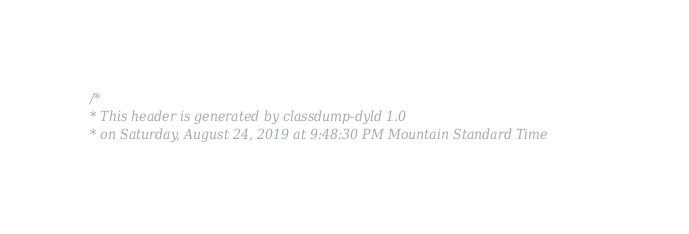<code> <loc_0><loc_0><loc_500><loc_500><_C_>/*
* This header is generated by classdump-dyld 1.0
* on Saturday, August 24, 2019 at 9:48:30 PM Mountain Standard Time</code> 